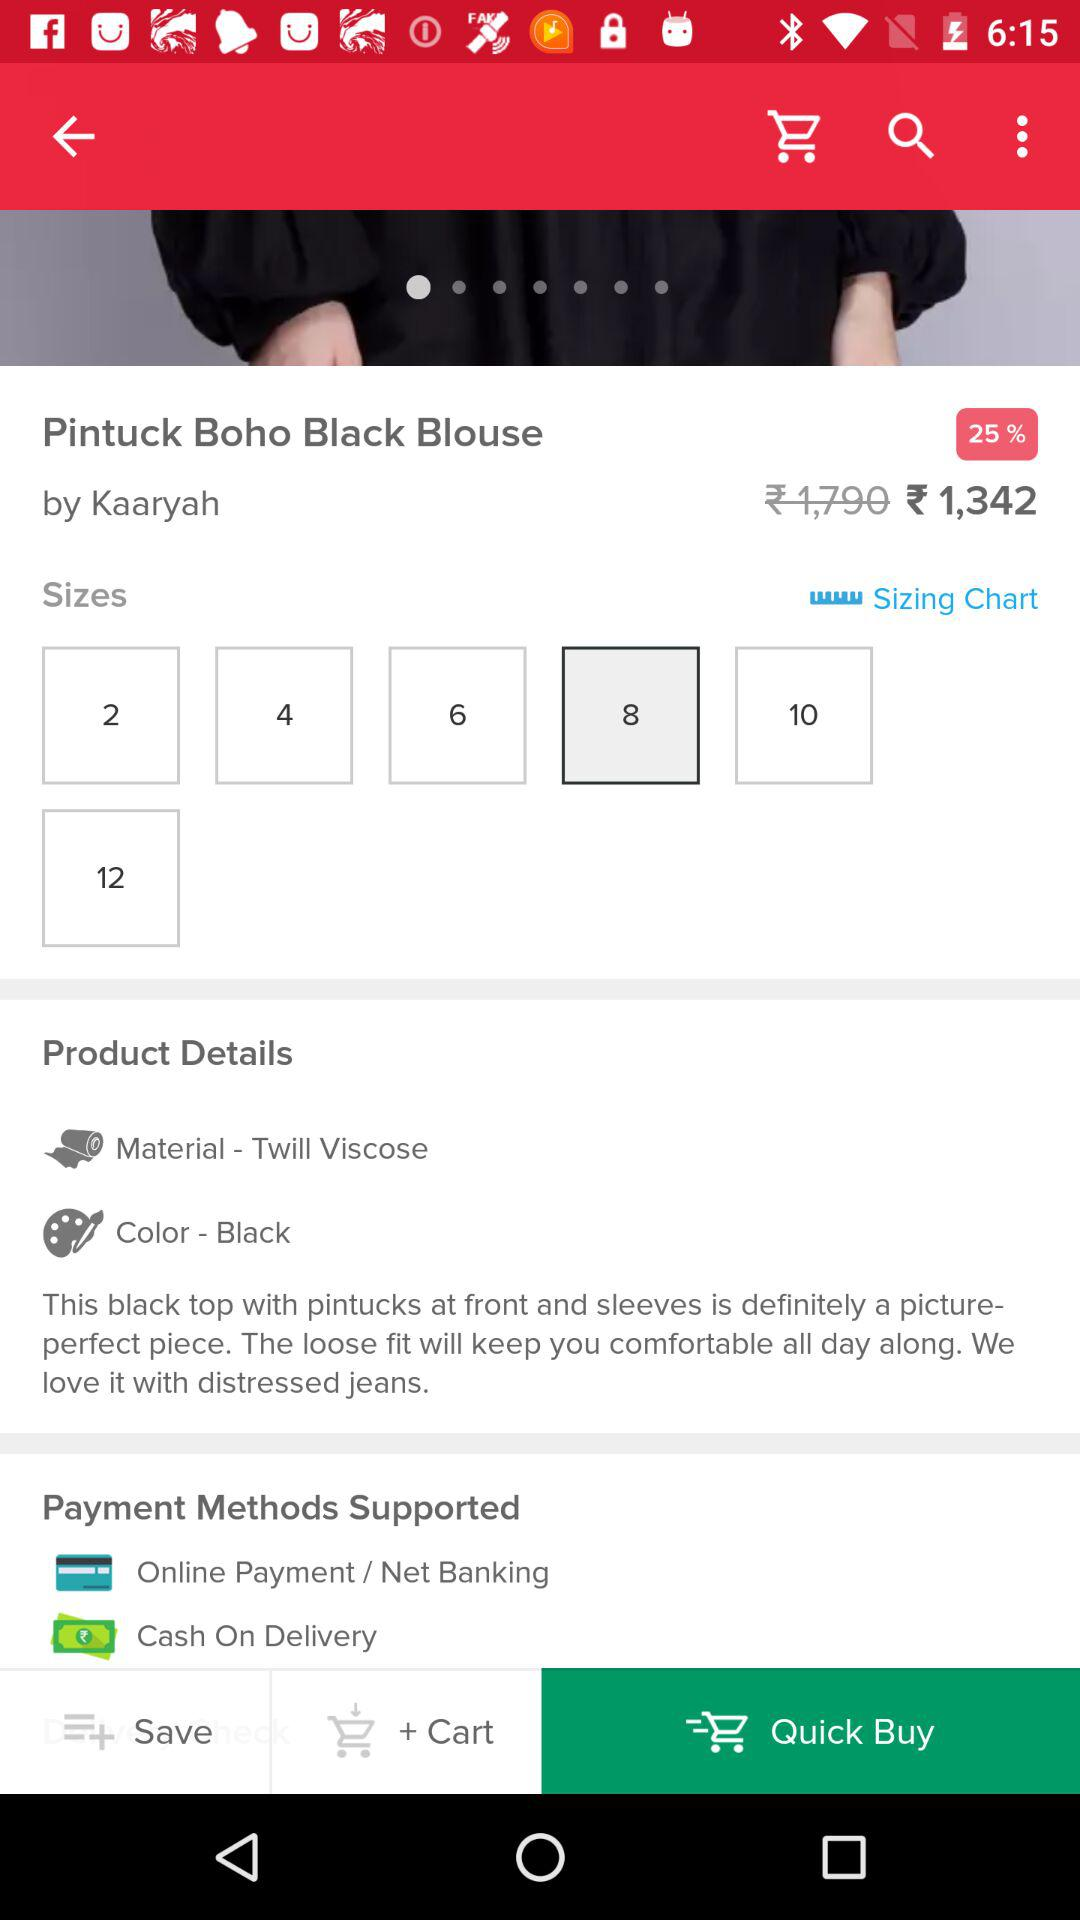What is the material of the product? The material of the product is "Twill Viscose". 